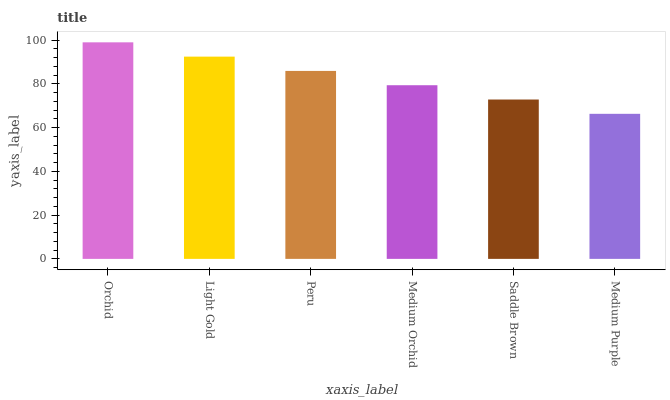Is Medium Purple the minimum?
Answer yes or no. Yes. Is Orchid the maximum?
Answer yes or no. Yes. Is Light Gold the minimum?
Answer yes or no. No. Is Light Gold the maximum?
Answer yes or no. No. Is Orchid greater than Light Gold?
Answer yes or no. Yes. Is Light Gold less than Orchid?
Answer yes or no. Yes. Is Light Gold greater than Orchid?
Answer yes or no. No. Is Orchid less than Light Gold?
Answer yes or no. No. Is Peru the high median?
Answer yes or no. Yes. Is Medium Orchid the low median?
Answer yes or no. Yes. Is Light Gold the high median?
Answer yes or no. No. Is Peru the low median?
Answer yes or no. No. 